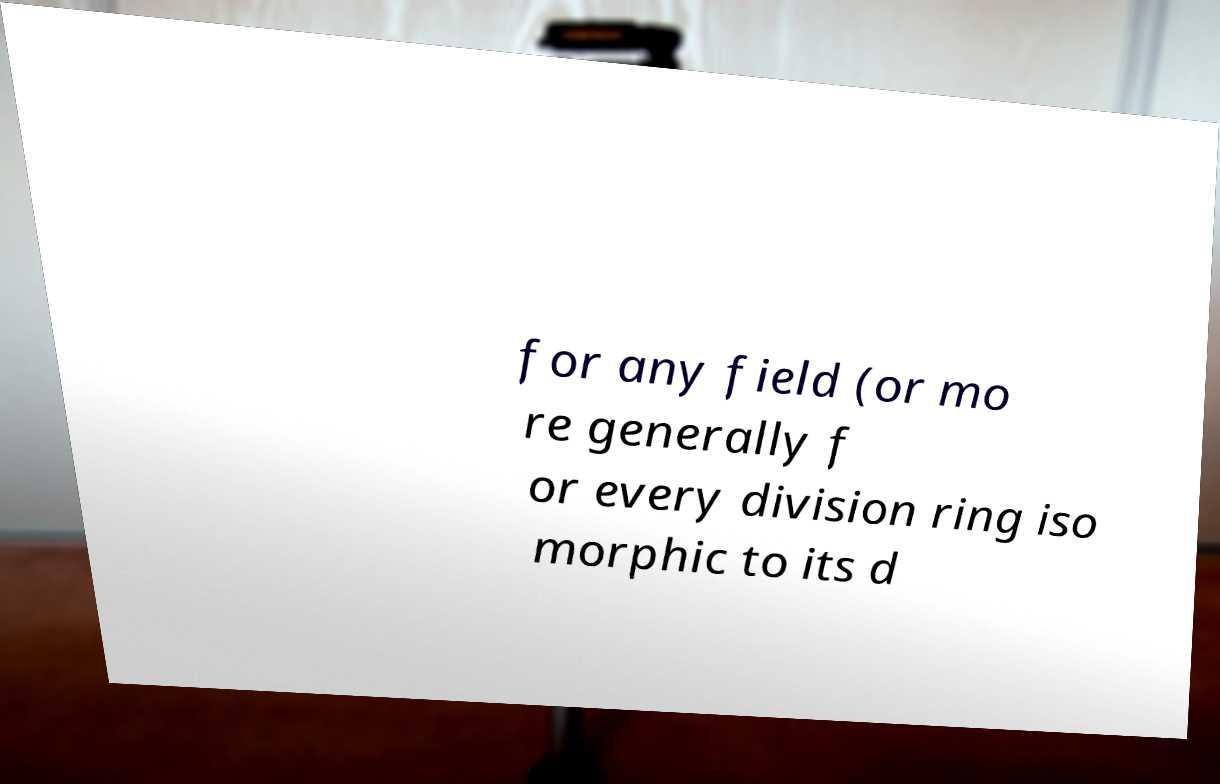For documentation purposes, I need the text within this image transcribed. Could you provide that? for any field (or mo re generally f or every division ring iso morphic to its d 